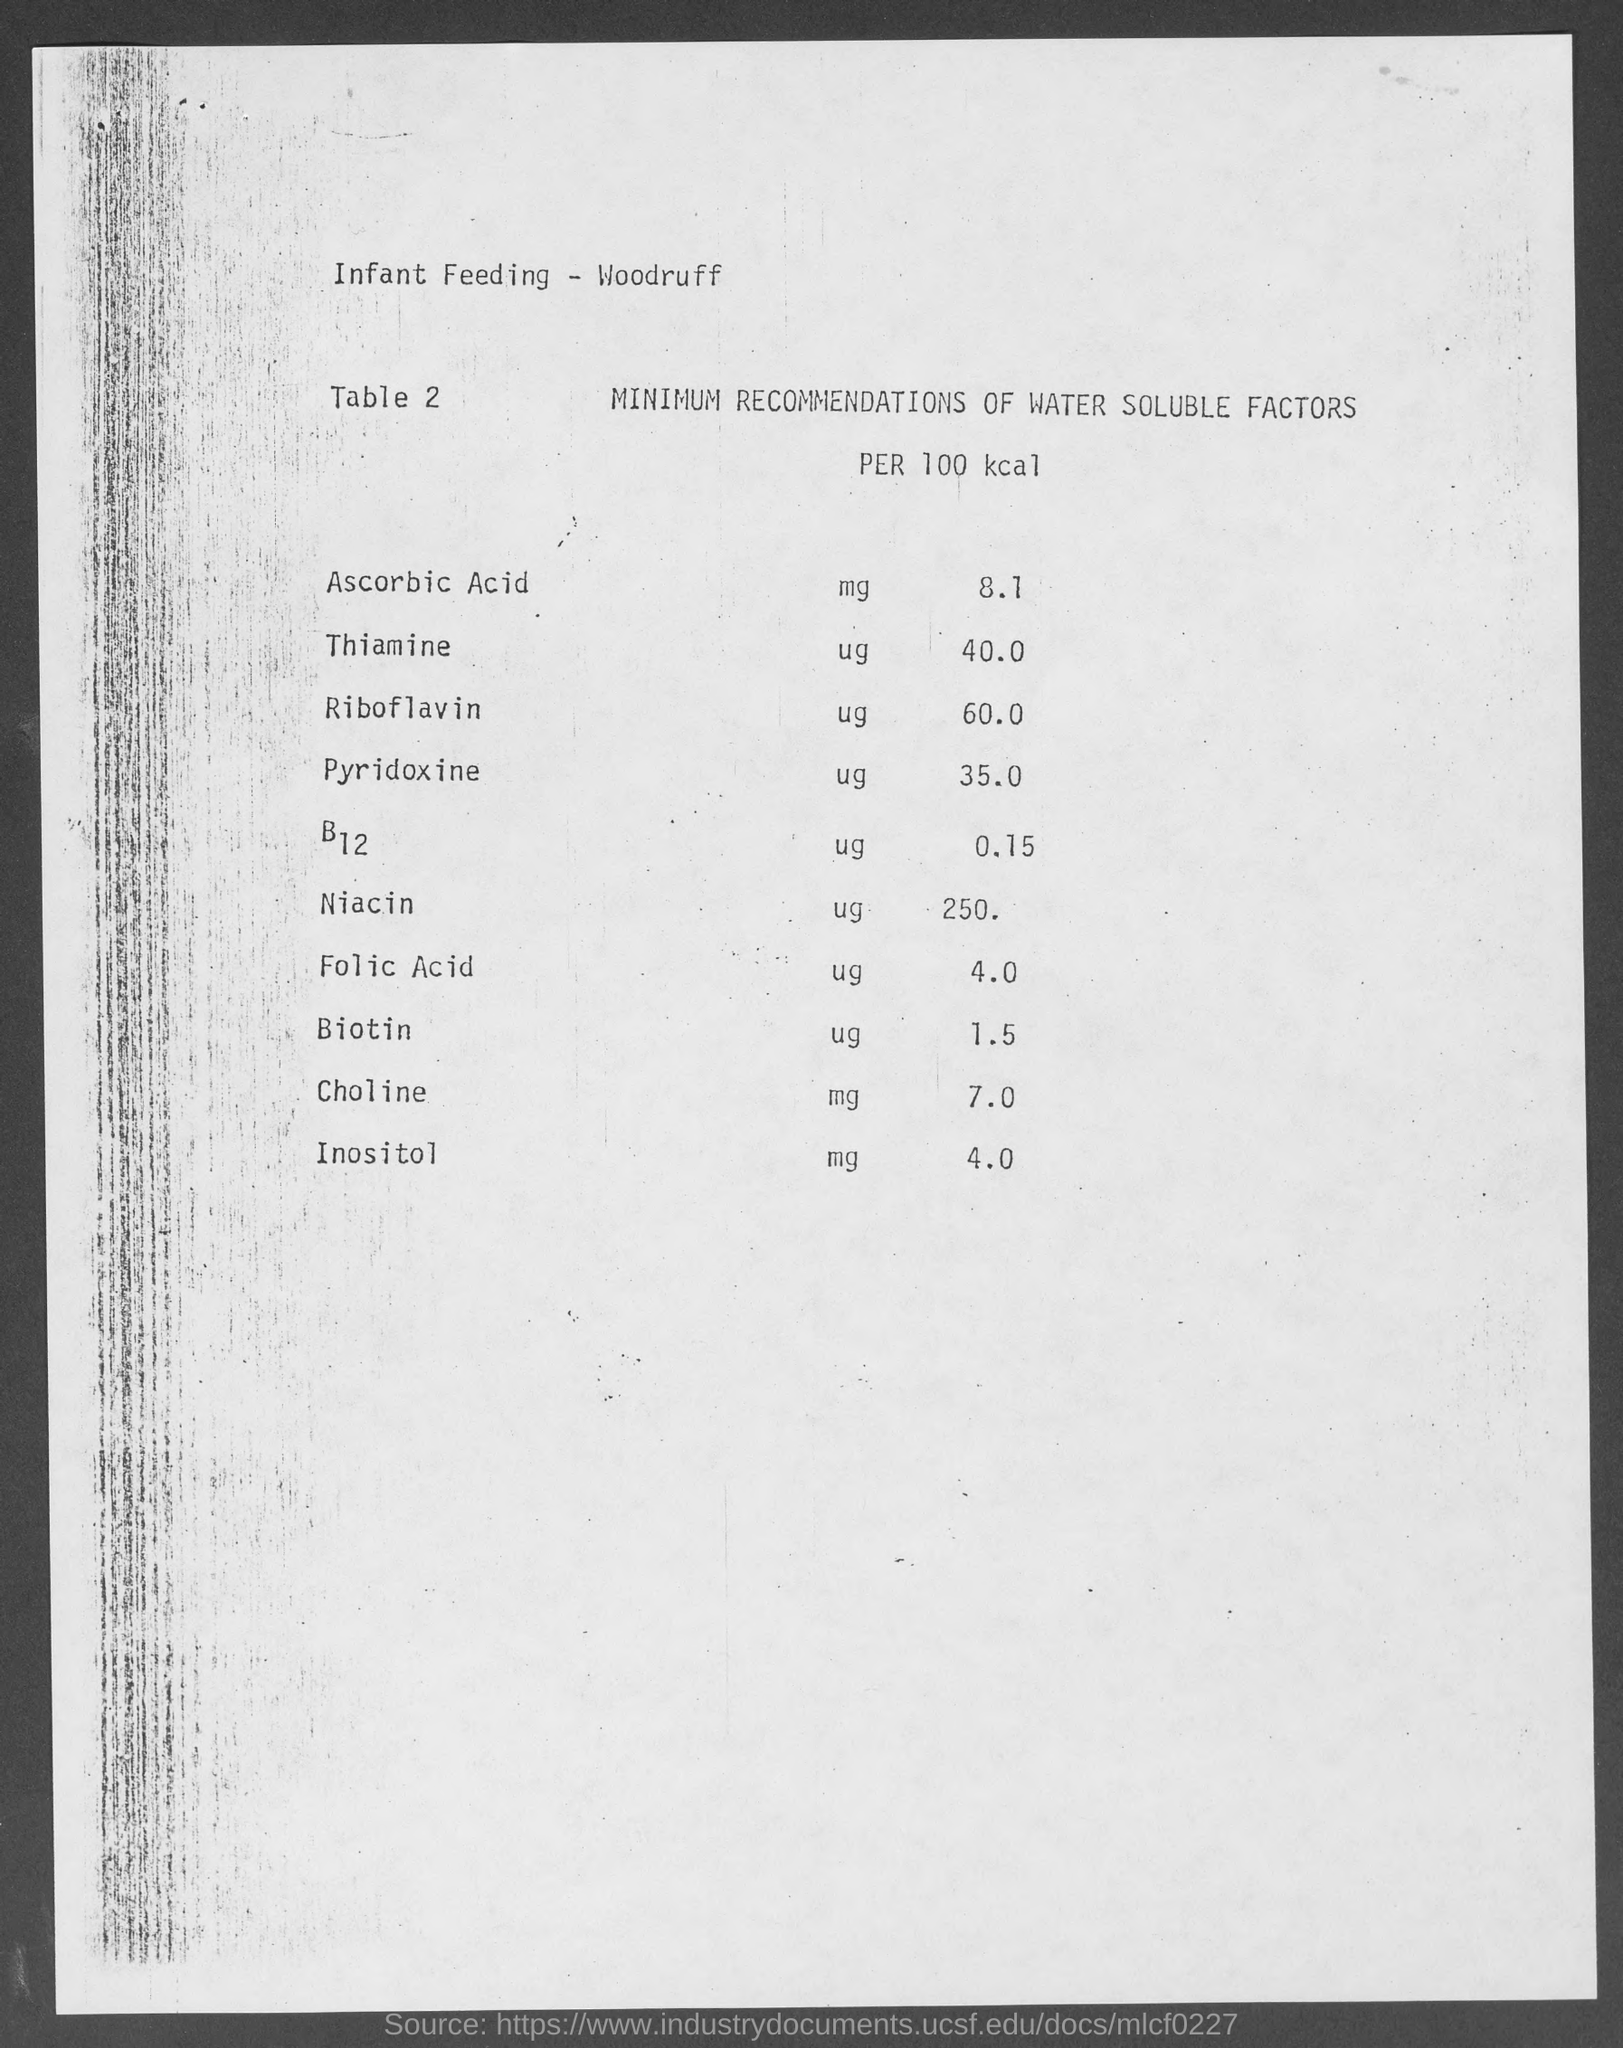Draw attention to some important aspects in this diagram. The choline mg value is 7.0. The UG value of B12 is 0.15. The mg value of ascorbic acid is 8.1. 